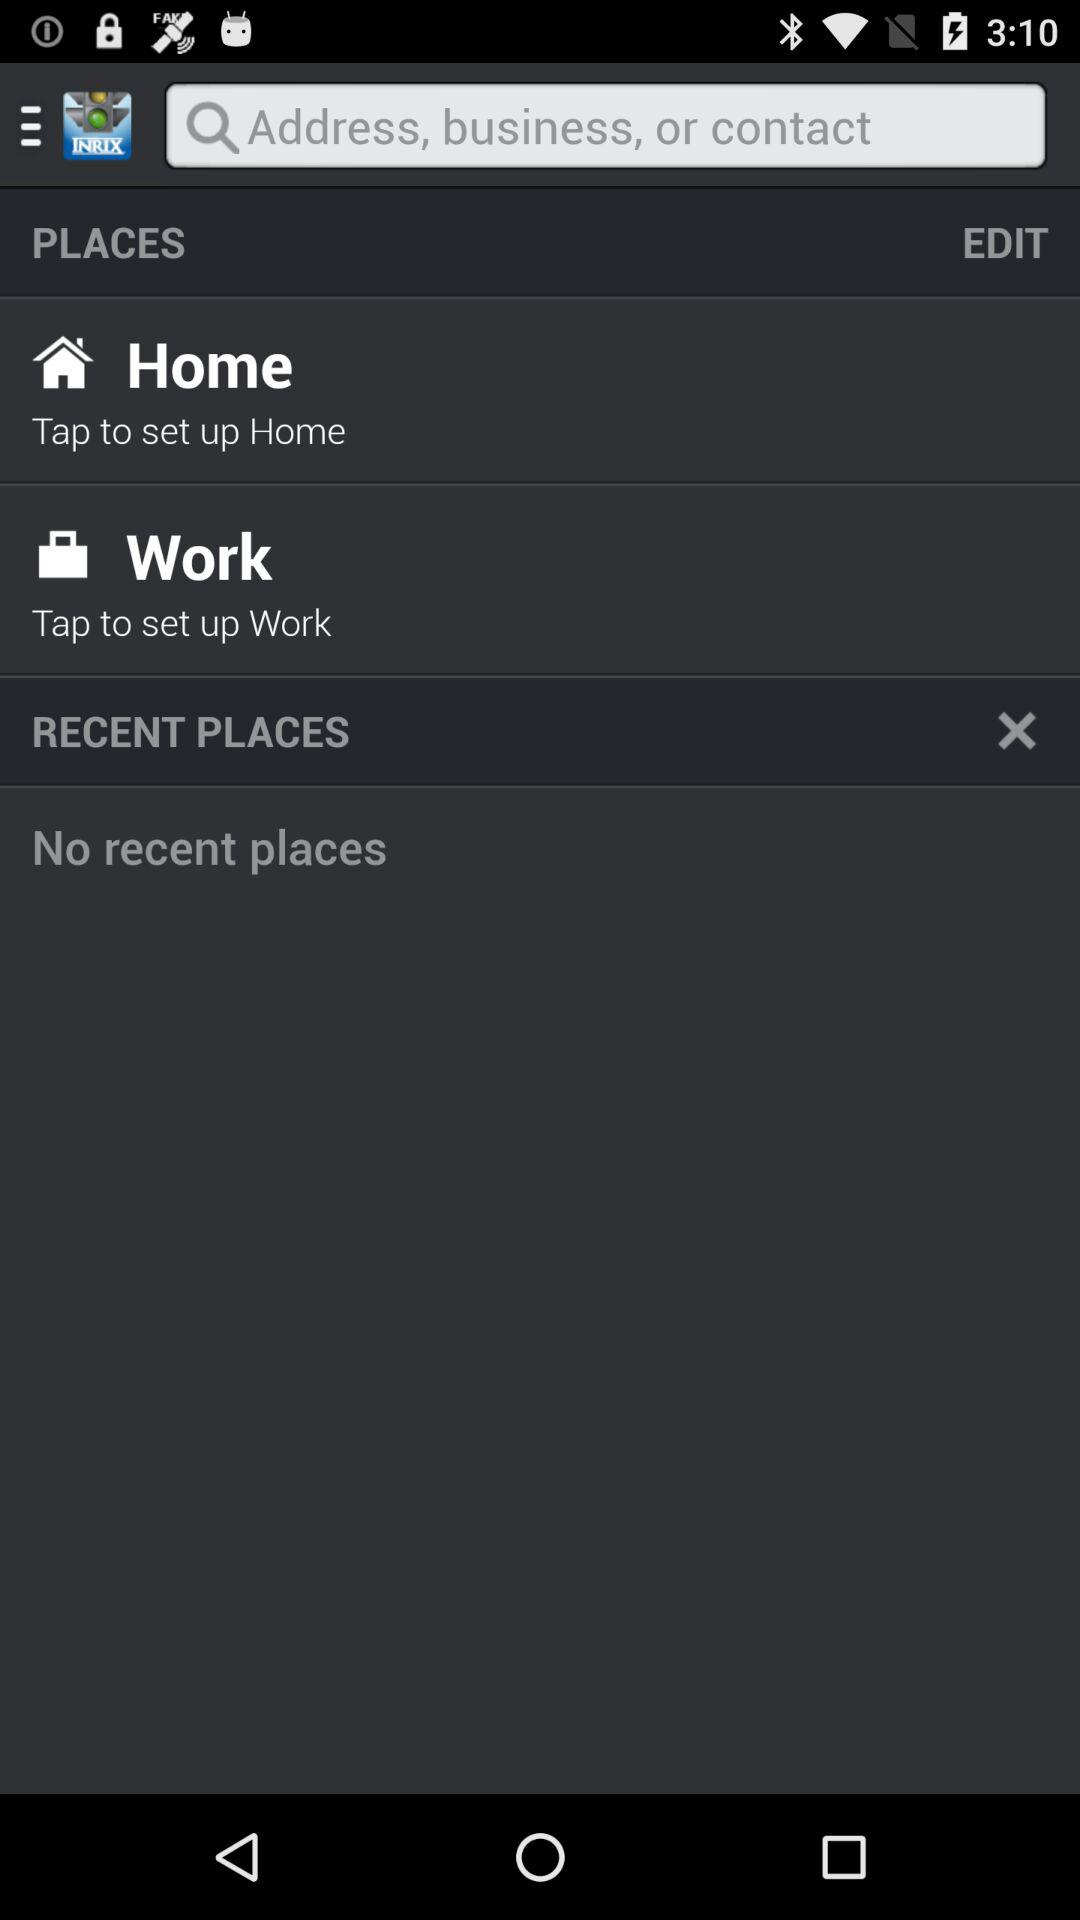Are there any recent places? There are no recent places. 